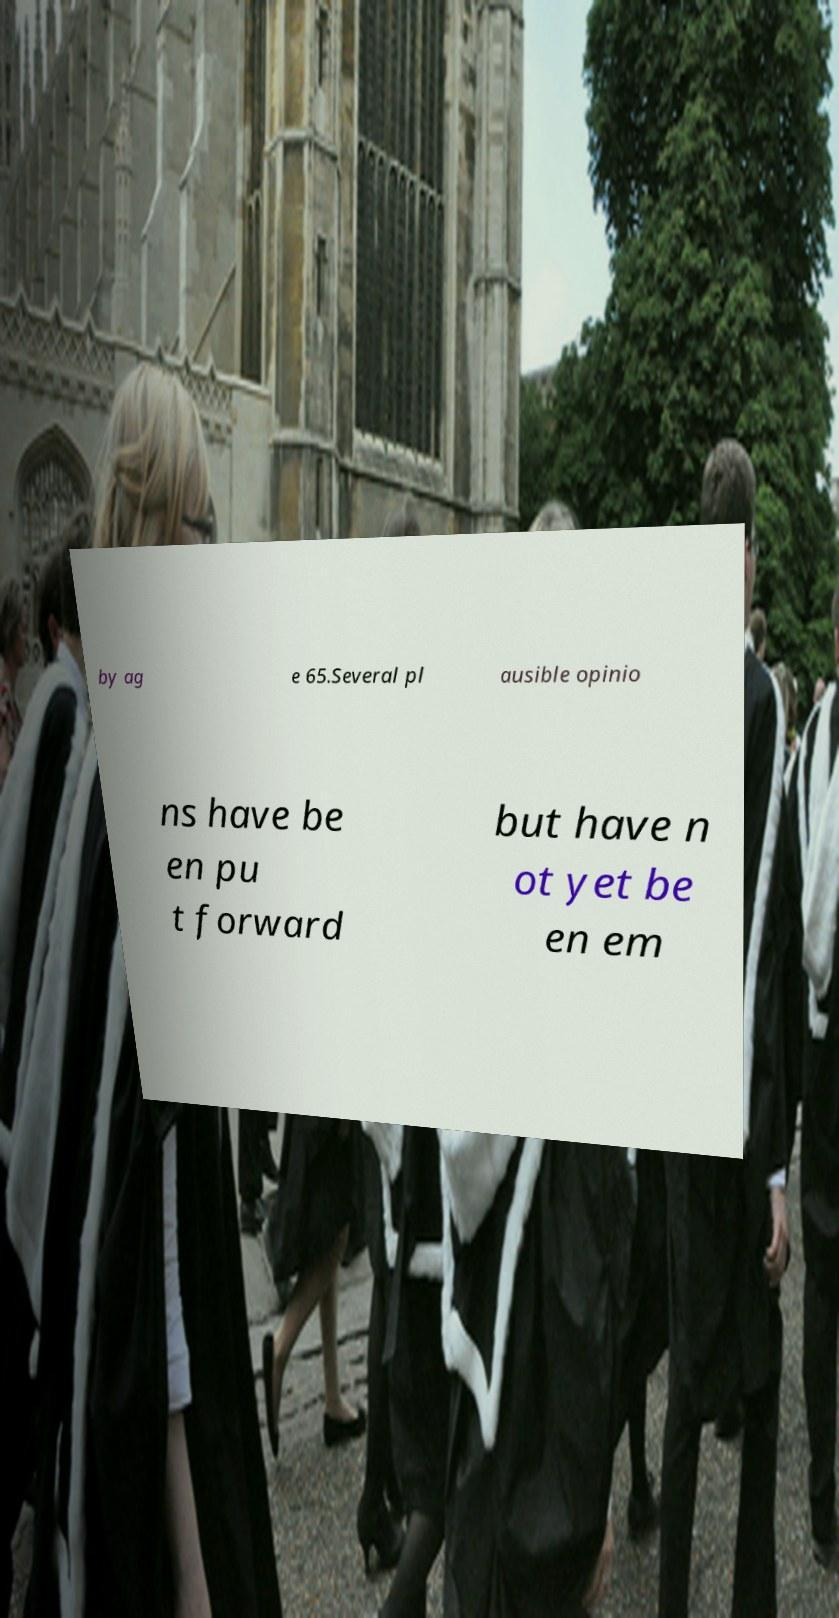Can you read and provide the text displayed in the image?This photo seems to have some interesting text. Can you extract and type it out for me? by ag e 65.Several pl ausible opinio ns have be en pu t forward but have n ot yet be en em 